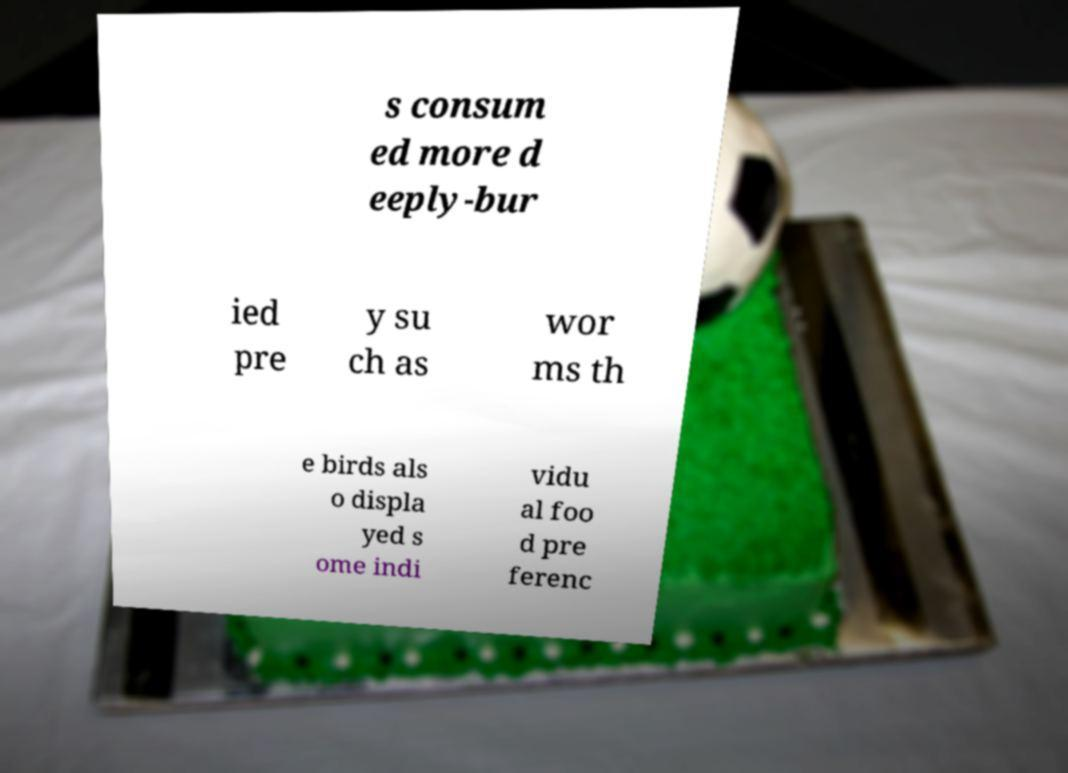There's text embedded in this image that I need extracted. Can you transcribe it verbatim? s consum ed more d eeply-bur ied pre y su ch as wor ms th e birds als o displa yed s ome indi vidu al foo d pre ferenc 